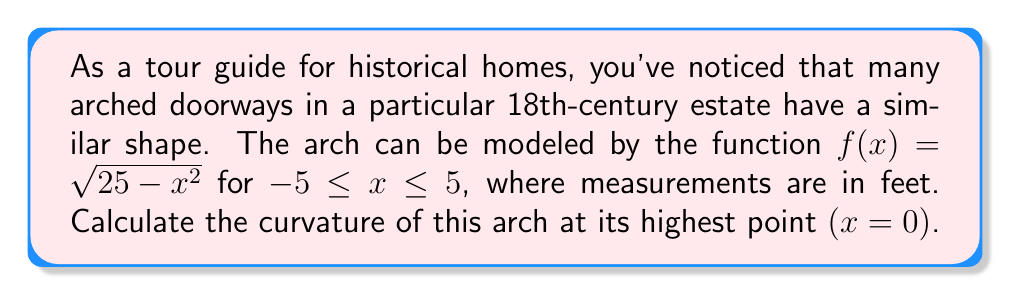Can you answer this question? To calculate the curvature of the arch at its highest point, we'll follow these steps:

1) The formula for curvature $K$ at any point $(x, f(x))$ is:

   $$K = \frac{|f''(x)|}{(1 + [f'(x)]^2)^{3/2}}$$

2) We need to find $f'(x)$ and $f''(x)$:

   $f(x) = \sqrt{25 - x^2} = (25 - x^2)^{1/2}$

   $f'(x) = \frac{1}{2}(25 - x^2)^{-1/2} \cdot (-2x) = \frac{-x}{\sqrt{25 - x^2}}$

   $f''(x) = \frac{-\sqrt{25 - x^2} + x \cdot \frac{x}{\sqrt{25 - x^2}}}{25 - x^2} = \frac{-25}{(25 - x^2)^{3/2}}$

3) At the highest point, x = 0. Let's evaluate $f'(0)$ and $f''(0)$:

   $f'(0) = \frac{-0}{\sqrt{25 - 0^2}} = 0$

   $f''(0) = \frac{-25}{(25 - 0^2)^{3/2}} = -\frac{1}{5}$

4) Now we can plug these values into the curvature formula:

   $$K = \frac{|-\frac{1}{5}|}{(1 + [0]^2)^{3/2}} = \frac{1}{5}$$

Therefore, the curvature of the arch at its highest point is $\frac{1}{5}$ ft^(-1).
Answer: $\frac{1}{5}$ ft^(-1) 